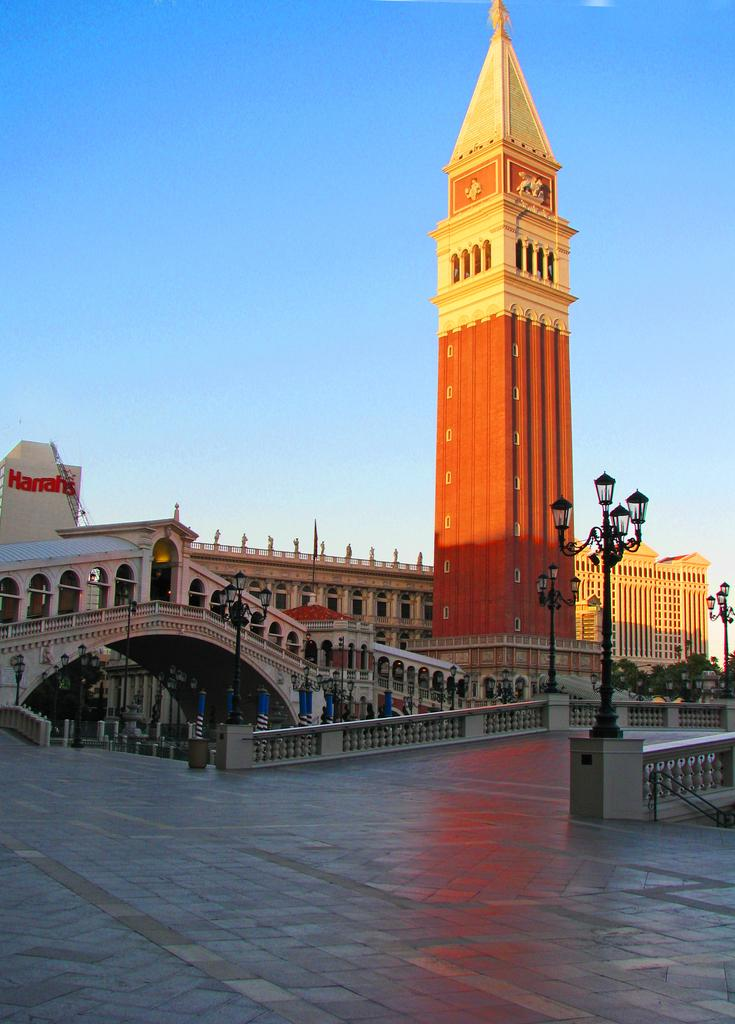What type of structures can be seen in the image? There are buildings in the image. What type of lighting is present in the image? There are street lamps in the image. Are there any architectural features visible in the image? Yes, there are stairs in the image. What is visible at the top of the image? The sky is visible at the top of the image. What channel is the boy watching on the television in the image? There is no boy or television present in the image. What type of food is the boy cooking in the image? There is no boy or cooking activity present in the image. 